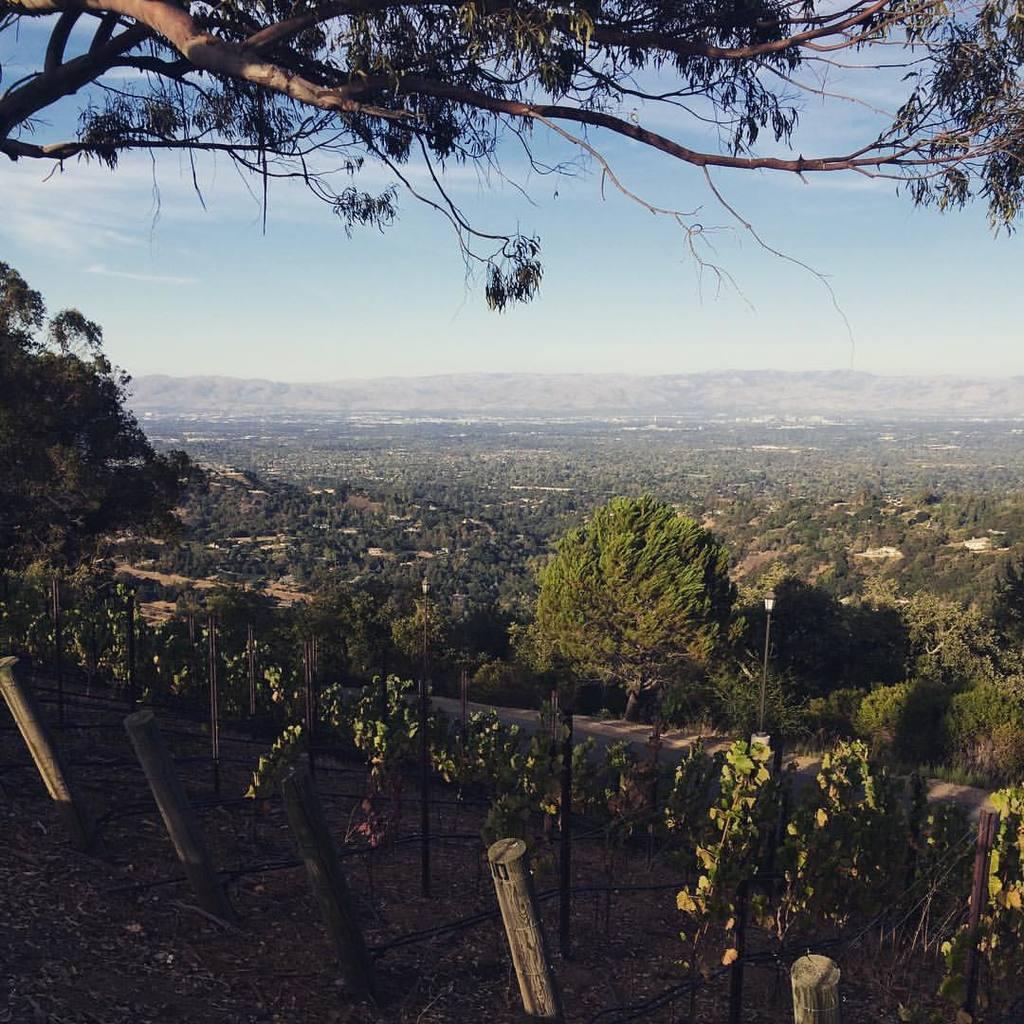How would you summarize this image in a sentence or two? In this picture we can see few plants, poles, trees and lights, in the background we can see hills and clouds. 